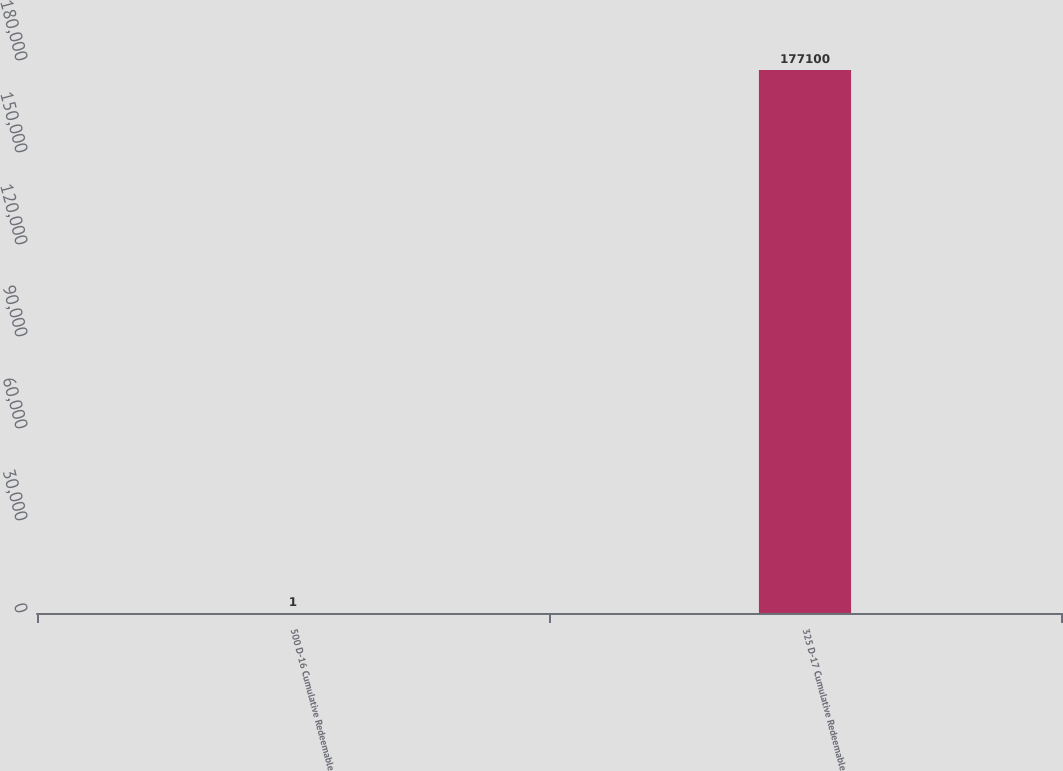Convert chart to OTSL. <chart><loc_0><loc_0><loc_500><loc_500><bar_chart><fcel>500 D-16 Cumulative Redeemable<fcel>325 D-17 Cumulative Redeemable<nl><fcel>1<fcel>177100<nl></chart> 